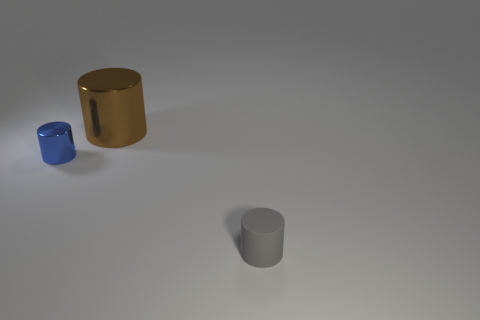Add 2 big metallic cylinders. How many objects exist? 5 Add 1 blue spheres. How many blue spheres exist? 1 Subtract 0 gray blocks. How many objects are left? 3 Subtract all large cylinders. Subtract all large purple rubber blocks. How many objects are left? 2 Add 3 tiny gray cylinders. How many tiny gray cylinders are left? 4 